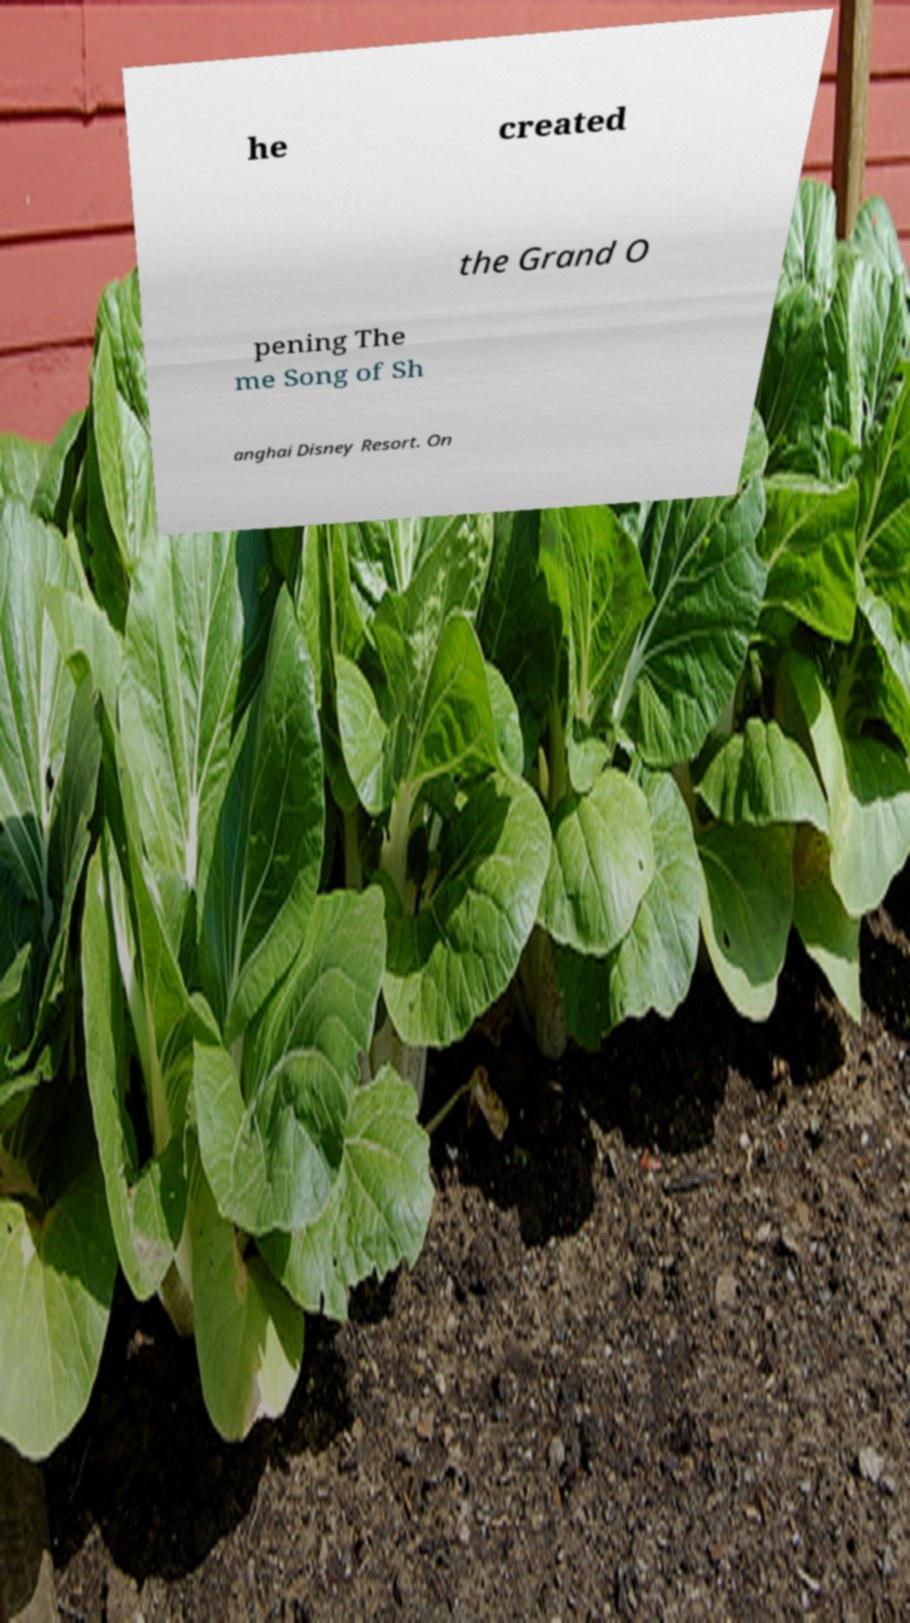For documentation purposes, I need the text within this image transcribed. Could you provide that? he created the Grand O pening The me Song of Sh anghai Disney Resort. On 